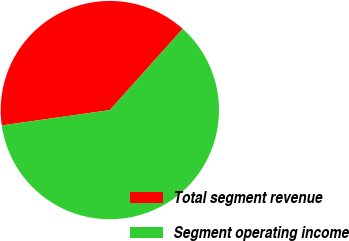<chart> <loc_0><loc_0><loc_500><loc_500><pie_chart><fcel>Total segment revenue<fcel>Segment operating income<nl><fcel>38.89%<fcel>61.11%<nl></chart> 